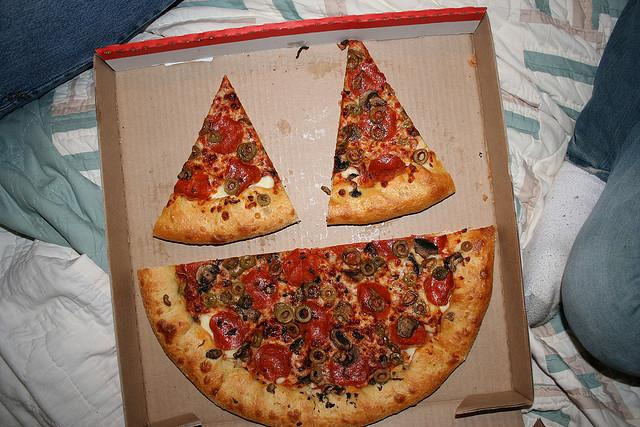Which topping contains the highest level of sodium? pepperoni 